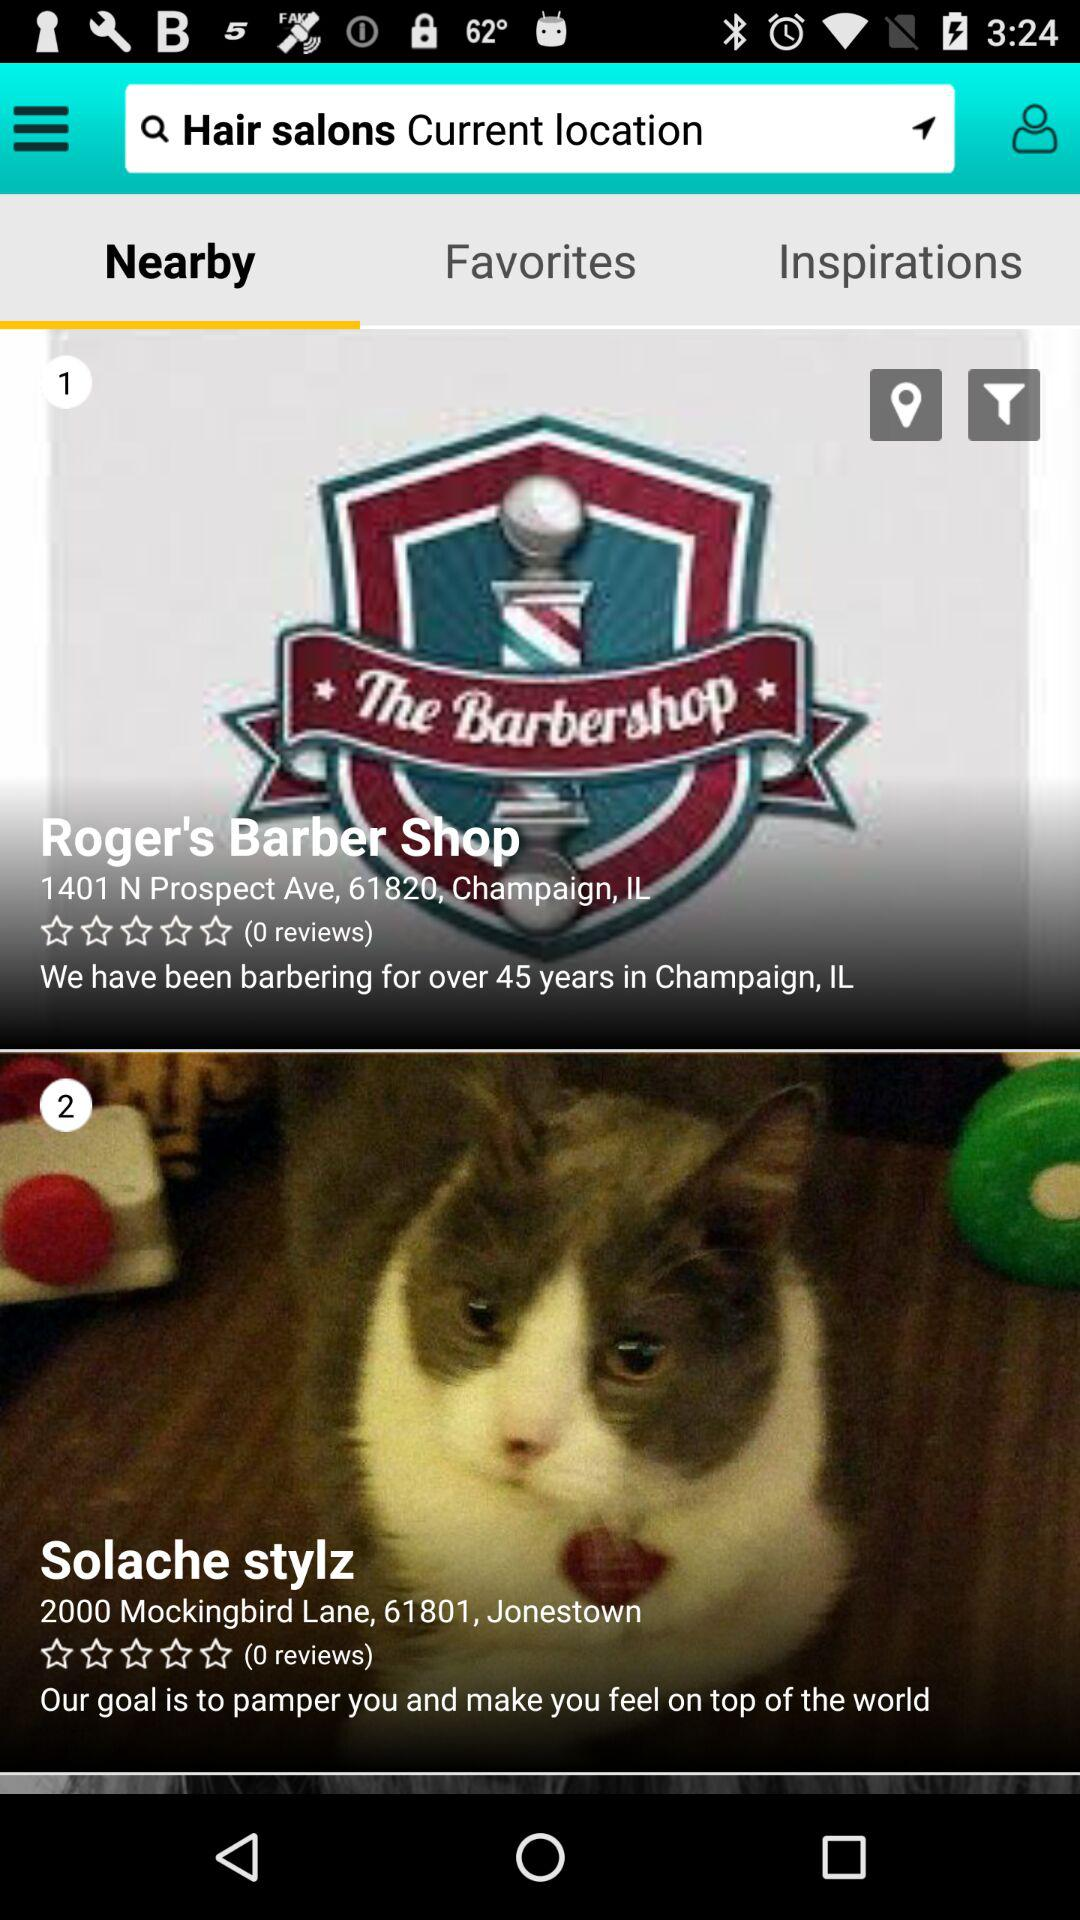How long has Roger's Barber Shop been barbering? Roger's Barber Shop has been barbering for over 45 years. 